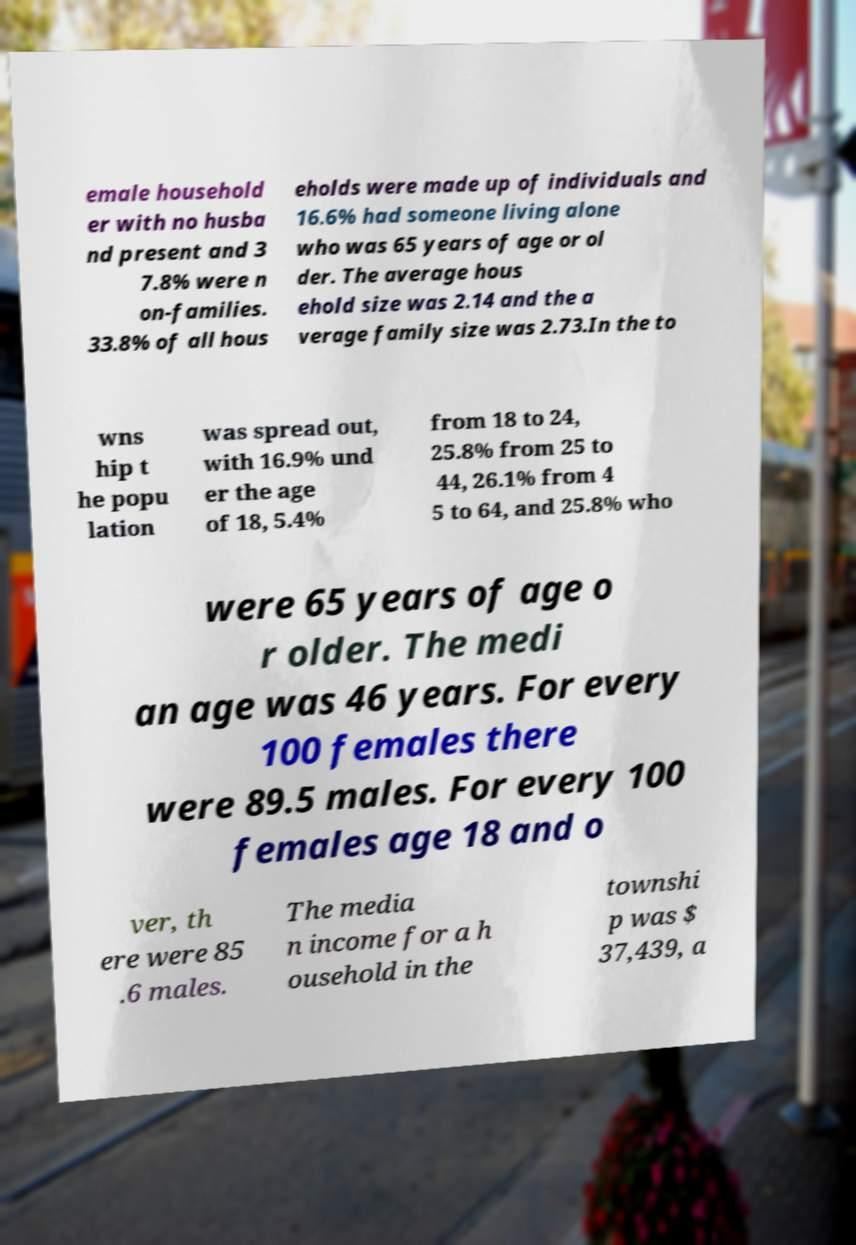There's text embedded in this image that I need extracted. Can you transcribe it verbatim? emale household er with no husba nd present and 3 7.8% were n on-families. 33.8% of all hous eholds were made up of individuals and 16.6% had someone living alone who was 65 years of age or ol der. The average hous ehold size was 2.14 and the a verage family size was 2.73.In the to wns hip t he popu lation was spread out, with 16.9% und er the age of 18, 5.4% from 18 to 24, 25.8% from 25 to 44, 26.1% from 4 5 to 64, and 25.8% who were 65 years of age o r older. The medi an age was 46 years. For every 100 females there were 89.5 males. For every 100 females age 18 and o ver, th ere were 85 .6 males. The media n income for a h ousehold in the townshi p was $ 37,439, a 